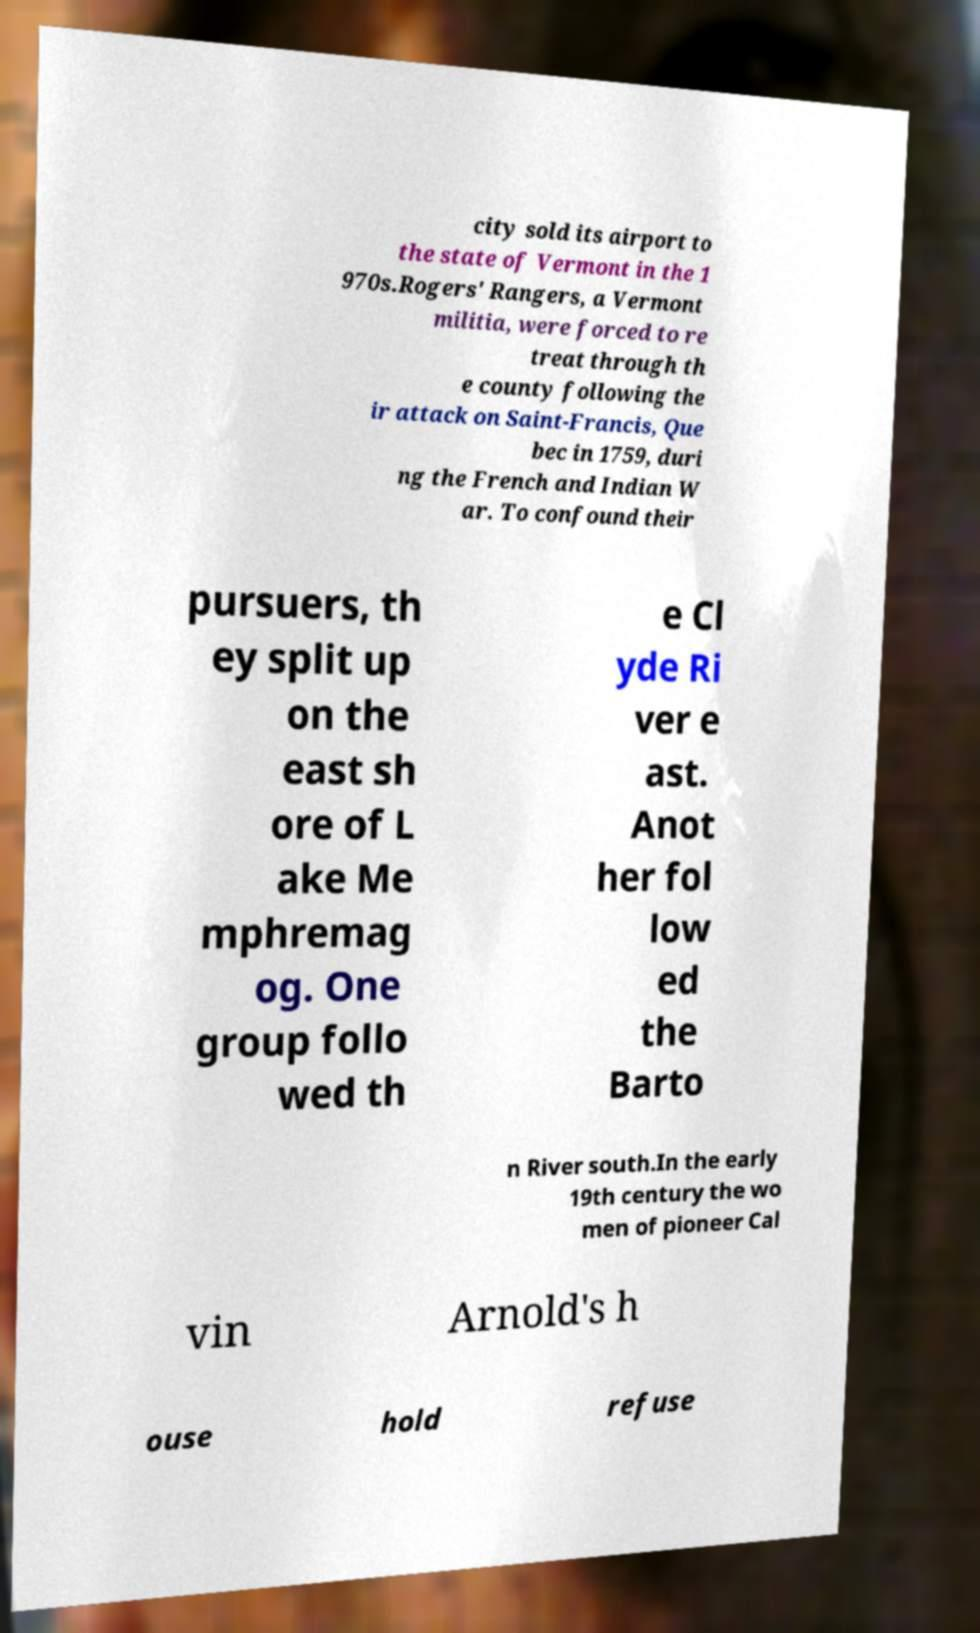Please identify and transcribe the text found in this image. city sold its airport to the state of Vermont in the 1 970s.Rogers' Rangers, a Vermont militia, were forced to re treat through th e county following the ir attack on Saint-Francis, Que bec in 1759, duri ng the French and Indian W ar. To confound their pursuers, th ey split up on the east sh ore of L ake Me mphremag og. One group follo wed th e Cl yde Ri ver e ast. Anot her fol low ed the Barto n River south.In the early 19th century the wo men of pioneer Cal vin Arnold's h ouse hold refuse 